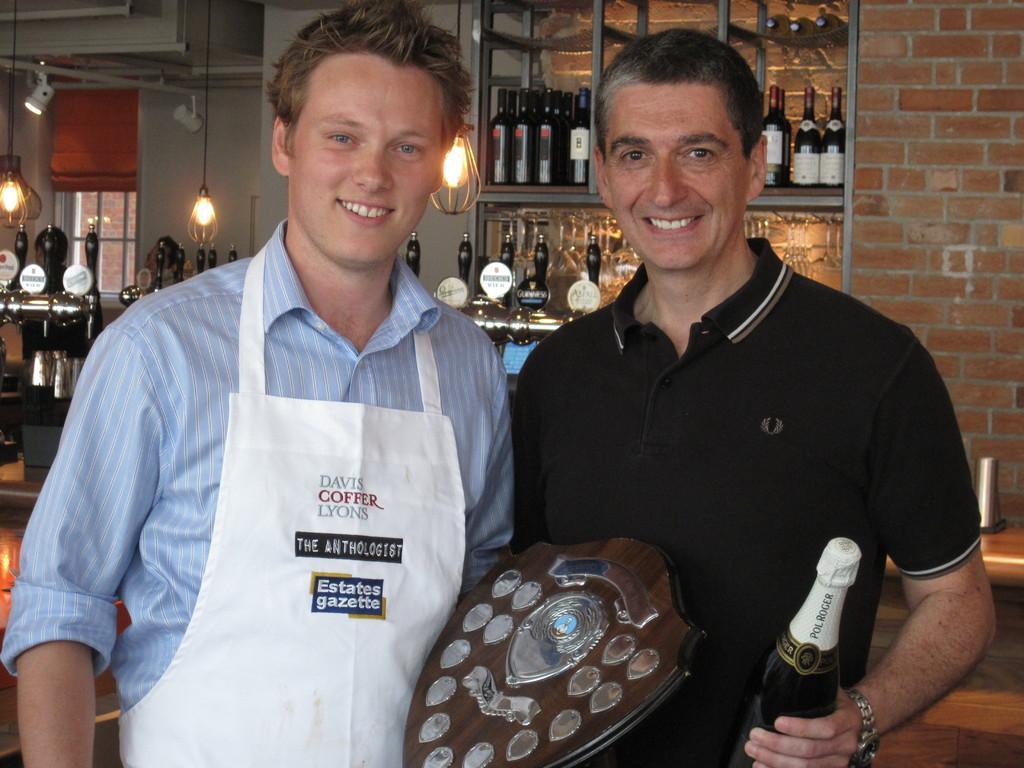How would you summarize this image in a sentence or two? Here we can see the both men are standing and holding a prize and bottle in his hand, and at back there are wine bottles in the rack, and here is the light. 